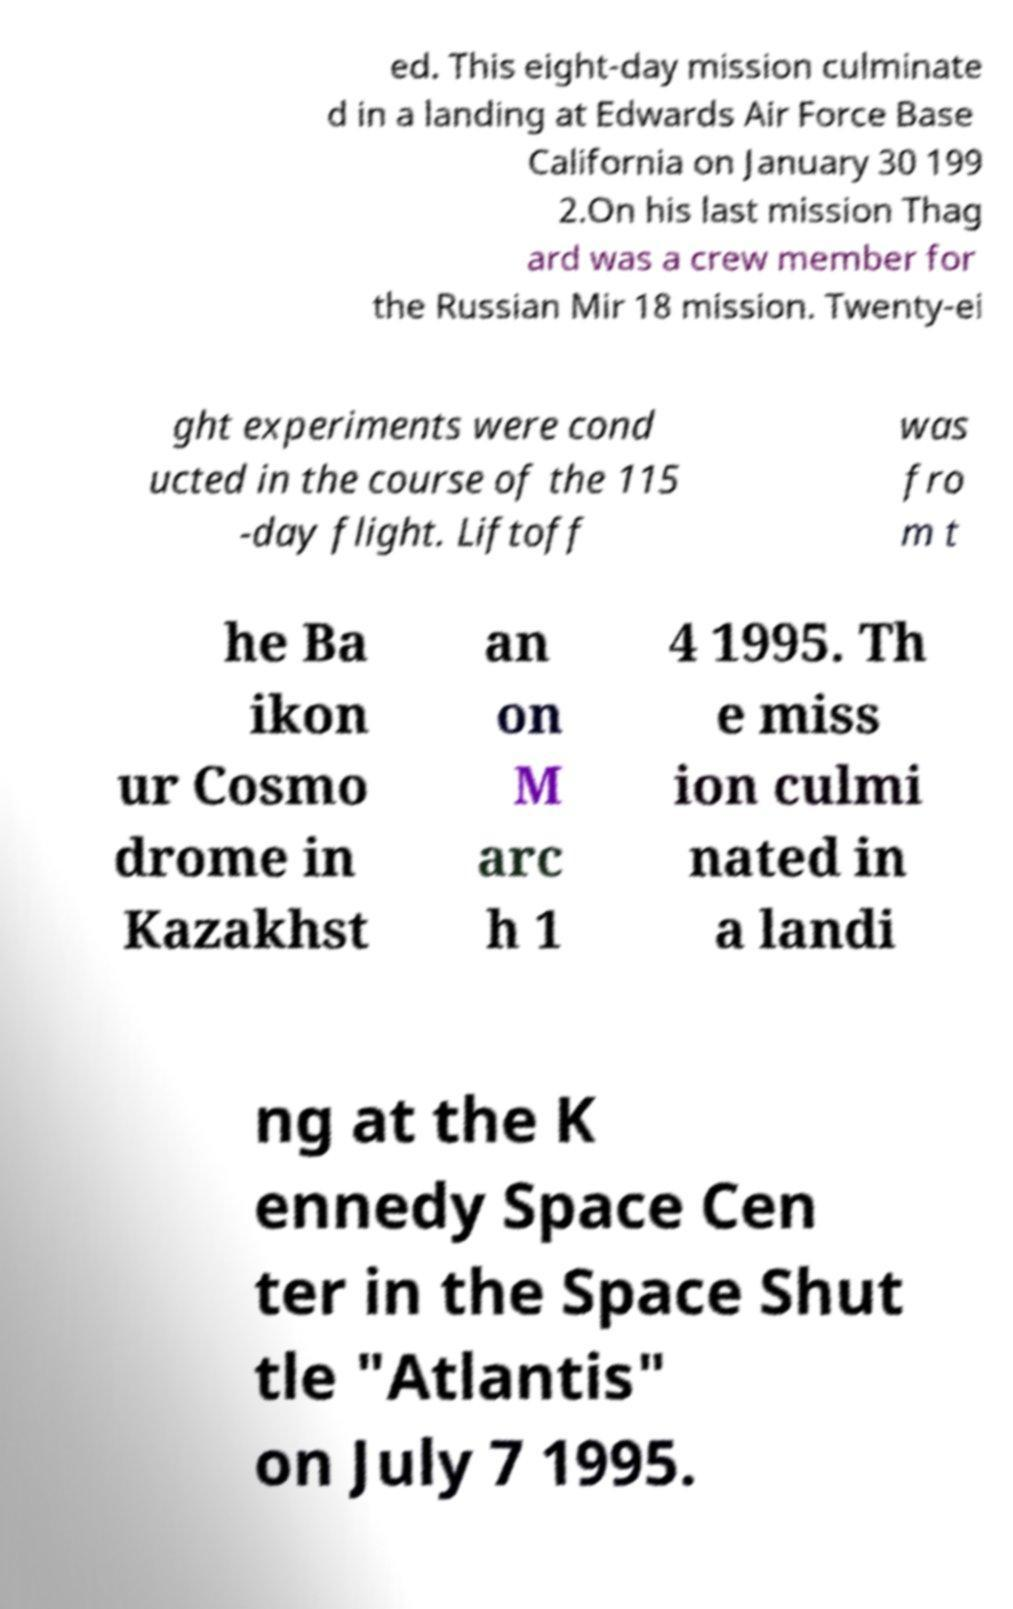Can you accurately transcribe the text from the provided image for me? ed. This eight-day mission culminate d in a landing at Edwards Air Force Base California on January 30 199 2.On his last mission Thag ard was a crew member for the Russian Mir 18 mission. Twenty-ei ght experiments were cond ucted in the course of the 115 -day flight. Liftoff was fro m t he Ba ikon ur Cosmo drome in Kazakhst an on M arc h 1 4 1995. Th e miss ion culmi nated in a landi ng at the K ennedy Space Cen ter in the Space Shut tle "Atlantis" on July 7 1995. 